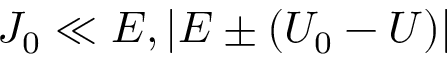<formula> <loc_0><loc_0><loc_500><loc_500>J _ { 0 } \ll E , | E \pm ( U _ { 0 } - U ) |</formula> 